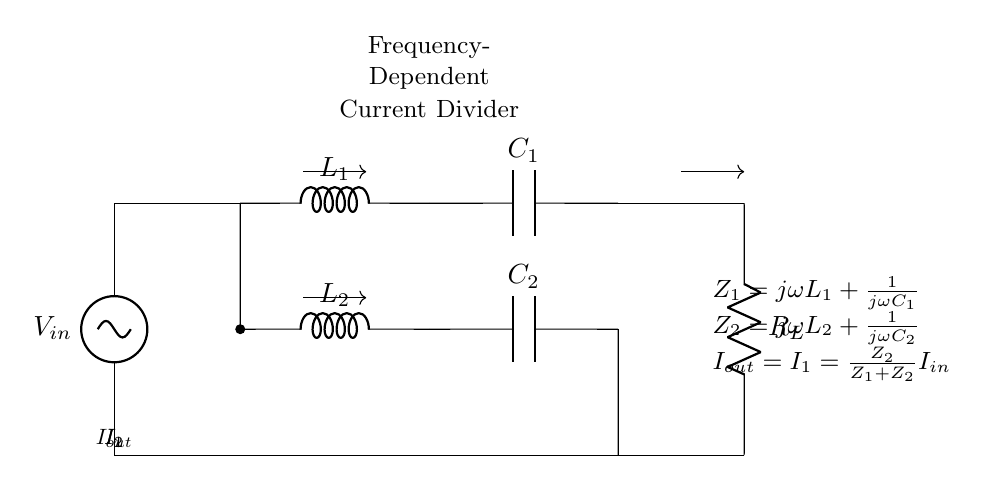What is the input voltage of this circuit? The input voltage is labeled as \( V_{in} \) in the circuit, located at the top left corner of the diagram.
Answer: \( V_{in} \) What are the components connected to node one? Node one is where the voltage source connects to the circuit. The components connected to this node are the inductor \( L_1 \) and capacitor \( C_1 \).
Answer: Inductor \( L_1 \) and capacitor \( C_1 \) What is the total current entering the circuit? The total current entering the circuit is \( I_{in} \), which branches into currents \( I_1 \) and \( I_2 \) as it reaches the first junction below the voltage source.
Answer: \( I_{in} \) What is the relationship between \( I_{out} \) and \( I_1 \)? The relationship is defined by the equation provided in the diagram: \( I_{out} = I_1 \), meaning that the output current is equal to the current through \( L_2 \) and \( C_2 \).
Answer: Equal What is the impedance of the first branch? The impedance of the first branch is described by the expression \( Z_1 = j\omega L_1 + \frac{1}{j\omega C_1} \). This indicates the use of both inductance and capacitance in this branch, affecting its behavior with frequency.
Answer: \( Z_1 = j\omega L_1 + \frac{1}{j\omega C_1} \) How does frequency affect the current division in this circuit? The frequency affects the impedance values of both branches, \( Z_1 \) and \( Z_2 \), dictating how the input current is divided between \( I_1 \) and \( I_2 \). As frequency changes, the reactance of \( L_1 \), \( L_2 \), \( C_1 \), and \( C_2 \) changes, impacting current distribution.
Answer: Frequency-dependent division What type of filtering can this circuit perform? This circuit acts as a filter, specifically a frequency-dependent current divider, which can attenuate specific frequency ranges while allowing others to pass based on the values of components used.
Answer: Frequency-dependent filtering 